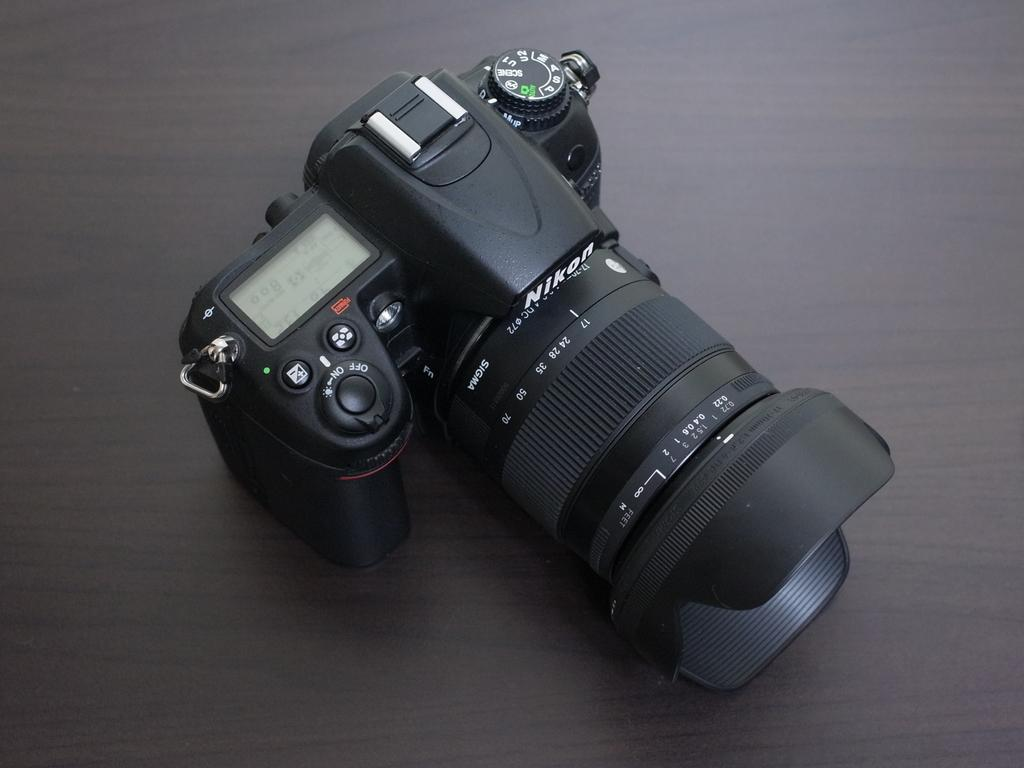Provide a one-sentence caption for the provided image. A professional photo camera made by Nikon sits on a table. 